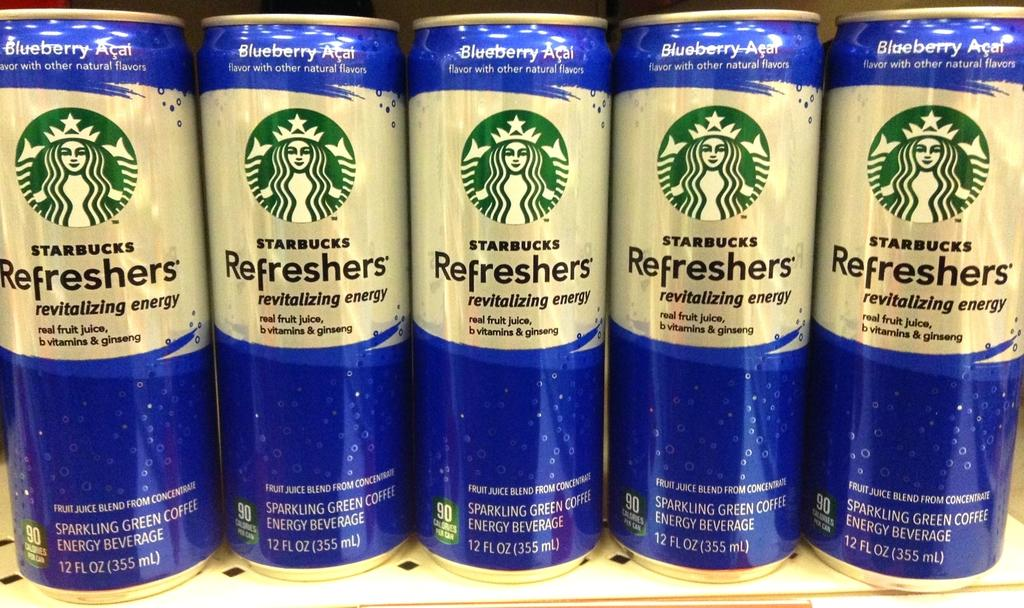Provide a one-sentence caption for the provided image. Five cans of a blueberry flavored Starbucks drink stand next to each other. 